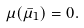<formula> <loc_0><loc_0><loc_500><loc_500>\mu ( \bar { \mu } _ { 1 } ) = 0 .</formula> 